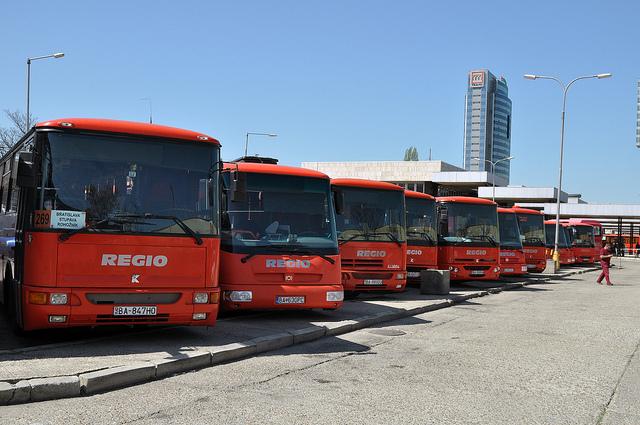What sort of event do these transports support?
Answer briefly. Special. What is in background?
Concise answer only. Building. How many red and white trucks are there?
Keep it brief. 10. How many buses are there?
Concise answer only. 9. What color are the buses?
Concise answer only. Red. 